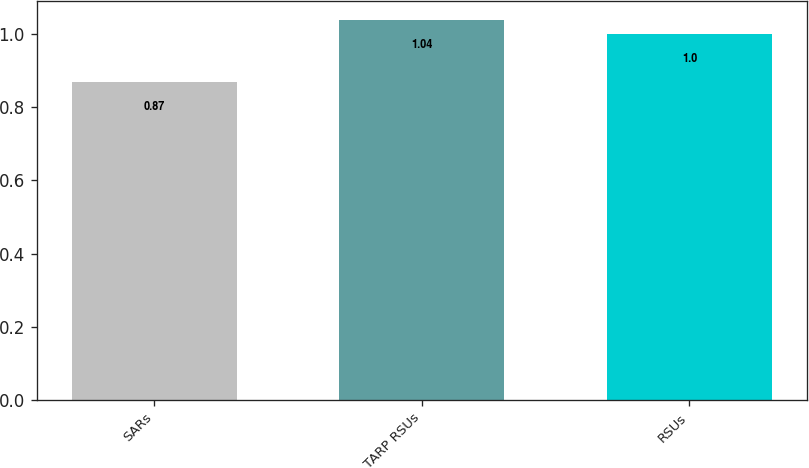<chart> <loc_0><loc_0><loc_500><loc_500><bar_chart><fcel>SARs<fcel>TARP RSUs<fcel>RSUs<nl><fcel>0.87<fcel>1.04<fcel>1<nl></chart> 